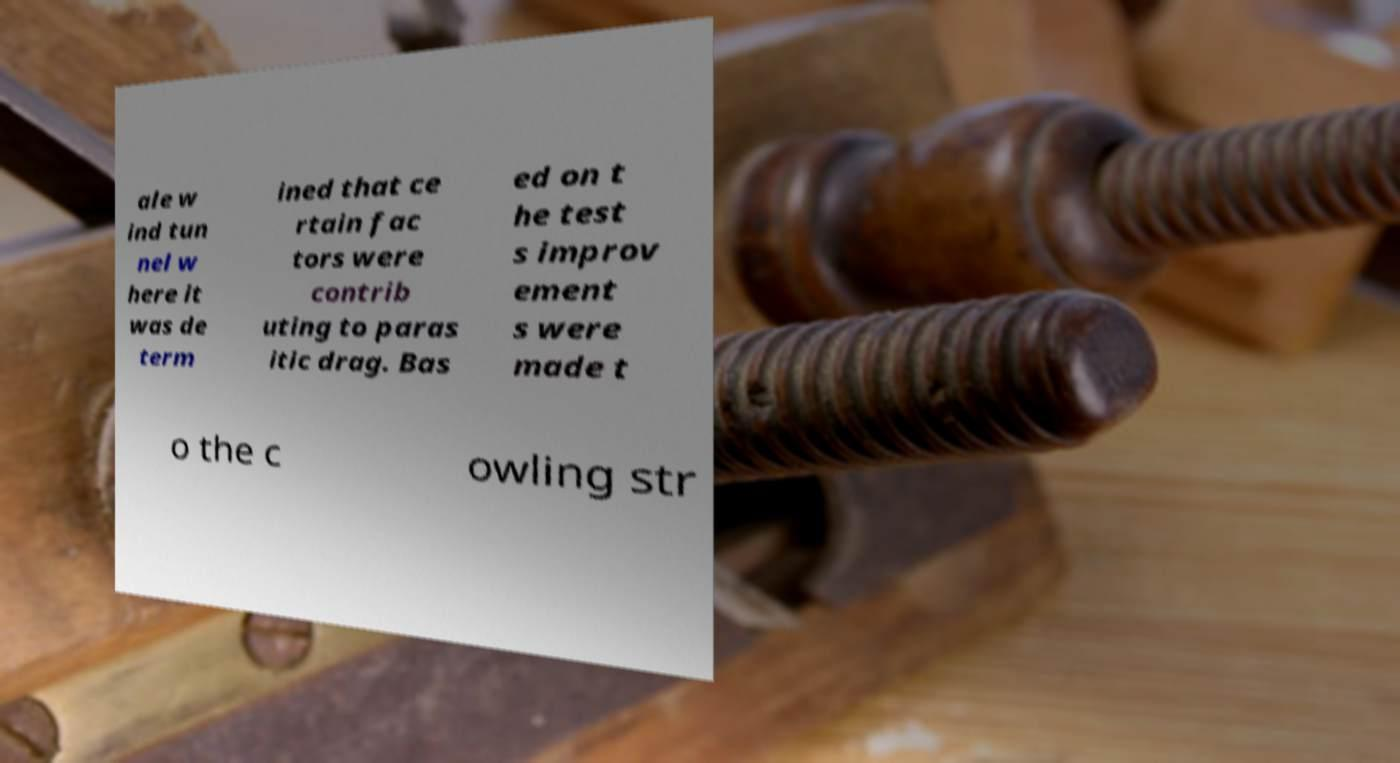Could you assist in decoding the text presented in this image and type it out clearly? ale w ind tun nel w here it was de term ined that ce rtain fac tors were contrib uting to paras itic drag. Bas ed on t he test s improv ement s were made t o the c owling str 